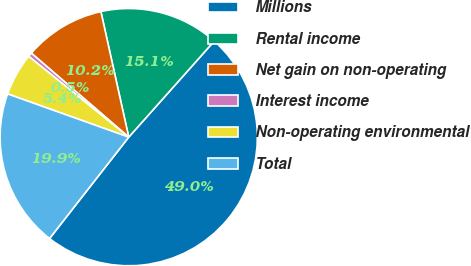Convert chart. <chart><loc_0><loc_0><loc_500><loc_500><pie_chart><fcel>Millions<fcel>Rental income<fcel>Net gain on non-operating<fcel>Interest income<fcel>Non-operating environmental<fcel>Total<nl><fcel>48.98%<fcel>15.05%<fcel>10.2%<fcel>0.51%<fcel>5.36%<fcel>19.9%<nl></chart> 